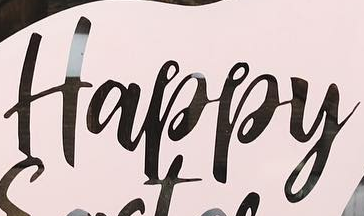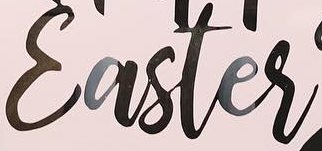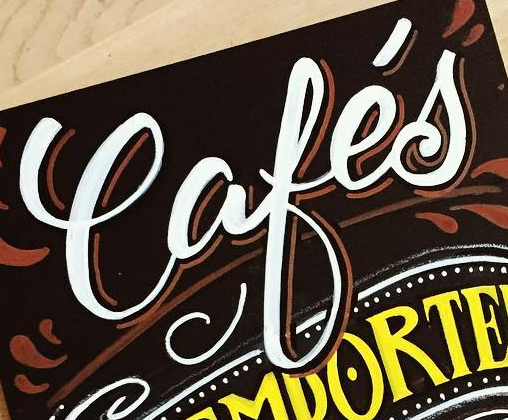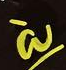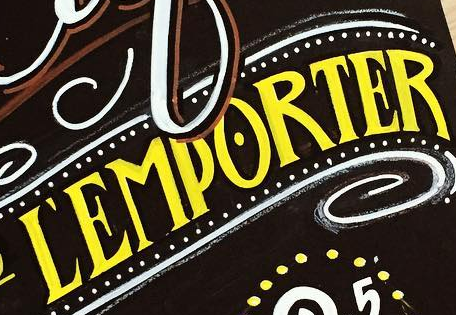What words can you see in these images in sequence, separated by a semicolon? Happy; Easter; Cafés; à; ĽEMPORTER 